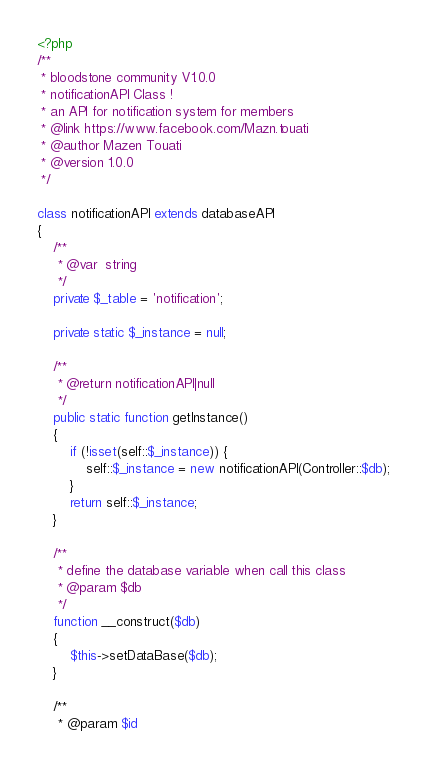Convert code to text. <code><loc_0><loc_0><loc_500><loc_500><_PHP_><?php
/**
 * bloodstone community V1.0.0
 * notificationAPI Class !
 * an API for notification system for members
 * @link https://www.facebook.com/Mazn.touati
 * @author Mazen Touati
 * @version 1.0.0
 */

class notificationAPI extends databaseAPI
{
    /**
     * @var  string
     */
    private $_table = 'notification';

    private static $_instance = null;

    /**
     * @return notificationAPI|null
     */
    public static function getInstance()
    {
        if (!isset(self::$_instance)) {
            self::$_instance = new notificationAPI(Controller::$db);
        }
        return self::$_instance;
    }

    /**
     * define the database variable when call this class
     * @param $db
     */
    function __construct($db)
    {
        $this->setDataBase($db);
    }

    /**
     * @param $id</code> 